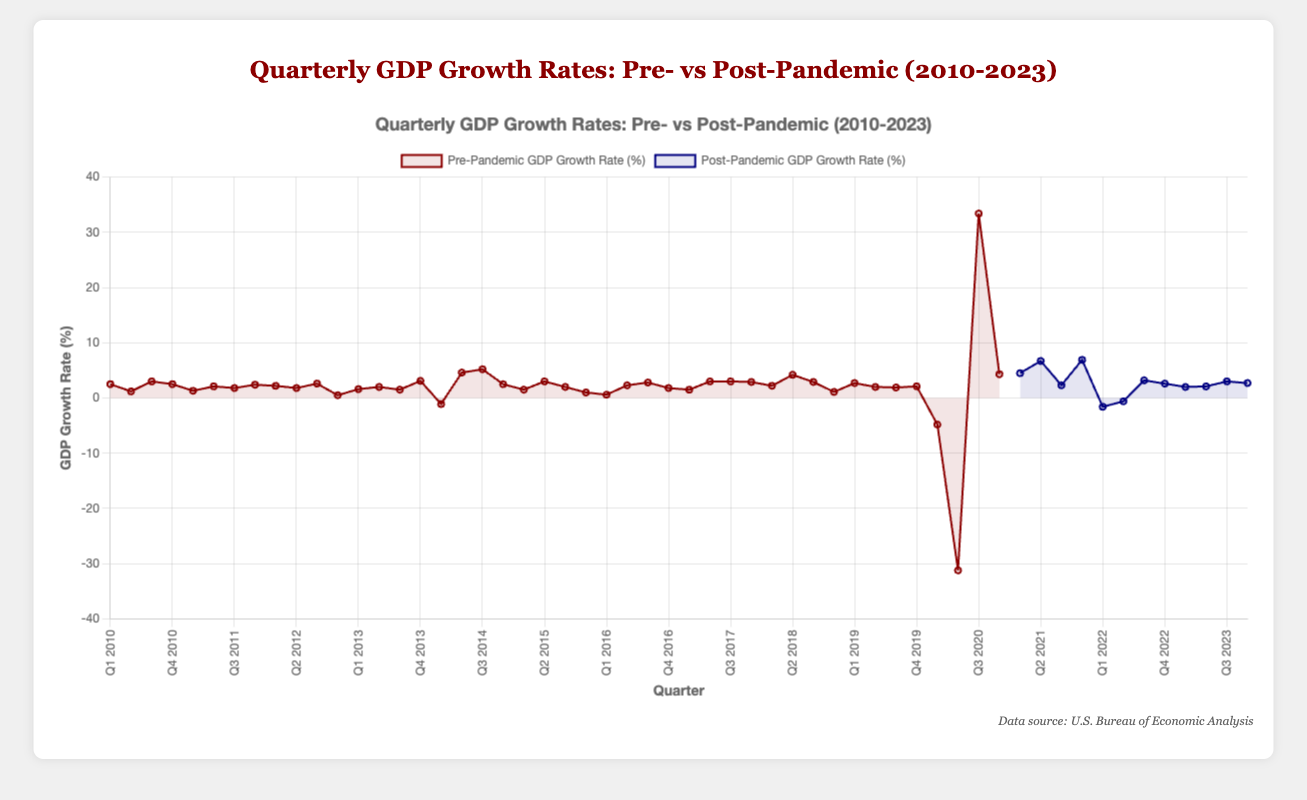What's the average pre-pandemic GDP growth rate in 2010? To find the average pre-pandemic GDP growth rate in 2010, sum the rates for all quarters in 2010 and divide by the number of quarters. The rates are 2.5, 1.2, 3.0, and 2.5. Sum them: 2.5 + 1.2 + 3.0 + 2.5 = 9.2. Divide by 4: 9.2 / 4 = 2.3
Answer: 2.3 How does the post-pandemic GDP growth rate in Q2 2021 compare to Q3 2023? Look at the graph to see the post-pandemic GDP growth rates for Q2 2021 and Q3 2023 and compare them visually. Q2 2021 has a rate of 6.7%, and Q3 2023 has a rate of 3.0%. 6.7% is greater than 3.0%.
Answer: 6.7% > 3.0% What quarter saw the highest post-pandemic GDP growth rate? Identify the highest point on the post-pandemic line in the graph. The highest rate is in Q4 2021 with a growth rate of 6.9%.
Answer: Q4 2021 During the pre-pandemic period, what was the biggest quarterly drop in GDP growth rate? Scan the pre-pandemic period for the largest single-quarter drop. The largest drop is from Q1 2020 to Q2 2020, with rates going from -4.8% to -31.2%, a drop of -26.4 percentage points.
Answer: Q2 2020 What is the combined GDP growth rate for post-pandemic Q1 2022 and Q2 2022? Find the growth rates for Q1 2022 (-1.6%) and Q2 2022 (-0.6%), then sum them: -1.6 + (-0.6) = -2.2
Answer: -2.2 Which year had the highest average pre-pandemic GDP growth rate? Calculate the annual average for each year by summing the quarterly rates and dividing by four. 2014 has the highest average with growth rates of -1.1, 4.6, 5.2, and 2.5. Sum: -1.1 + 4.6 + 5.2 + 2.5 = 11.2, average: 11.2 / 4 = 2.8.
Answer: 2014 How many quarters had negative GDP growth rates in the pre-pandemic period? Count all quarters with GDP growth rates less than 0 in the pre-pandemic data. They are Q1 2014 (-1.1) and Q1 2020 (-4.8, Q2 2020 (-31.2)).
Answer: 3 Which post-pandemic quarter shows the smallest GDP growth rate and what is its rate? Look for the lowest point in the post-pandemic line. The smallest rate is in Q1 2022 with -1.6%.
Answer: Q1 2022, -1.6% What was the trend in GDP growth rates for the post-pandemic period from Q1 2021 to Q4 2021? Observe the line for post-pandemic GDP growth rates between these quarters. The rates increase from Q1 2021 (4.5%) to Q4 2021 (6.9%) with a slight dip in Q3 2021 (2.3%).
Answer: Increasing trend with a slight dip in Q3 Compare the visual color distinction between pre-pandemic and post-pandemic growth rates. The pre-pandemic GDP growth rate line is shown in a shade of red, while the post-pandemic GDP growth rate line is in blue, making a clear visual distinction between the two periods.
Answer: Red vs Blue lines 